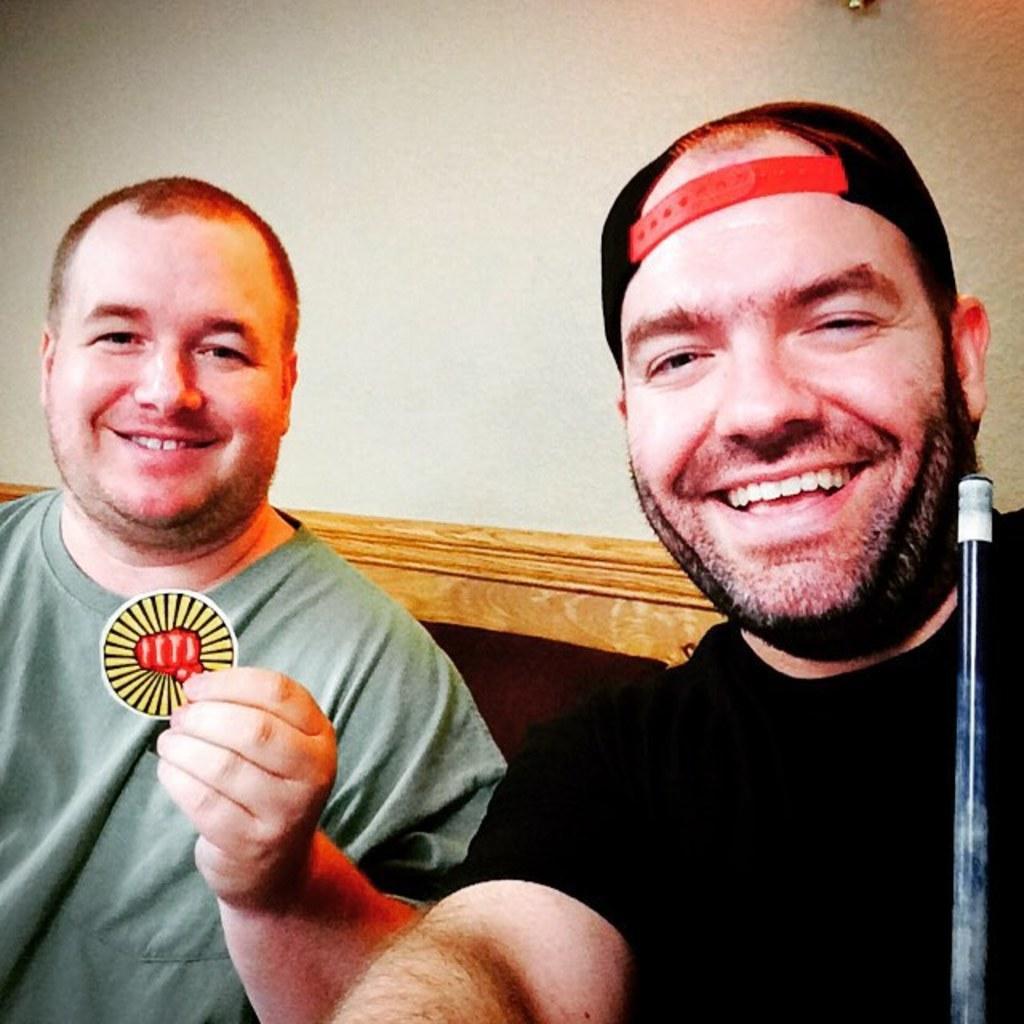Please provide a concise description of this image. In the center of the image we can see two persons sitting. In the background there is wall. 